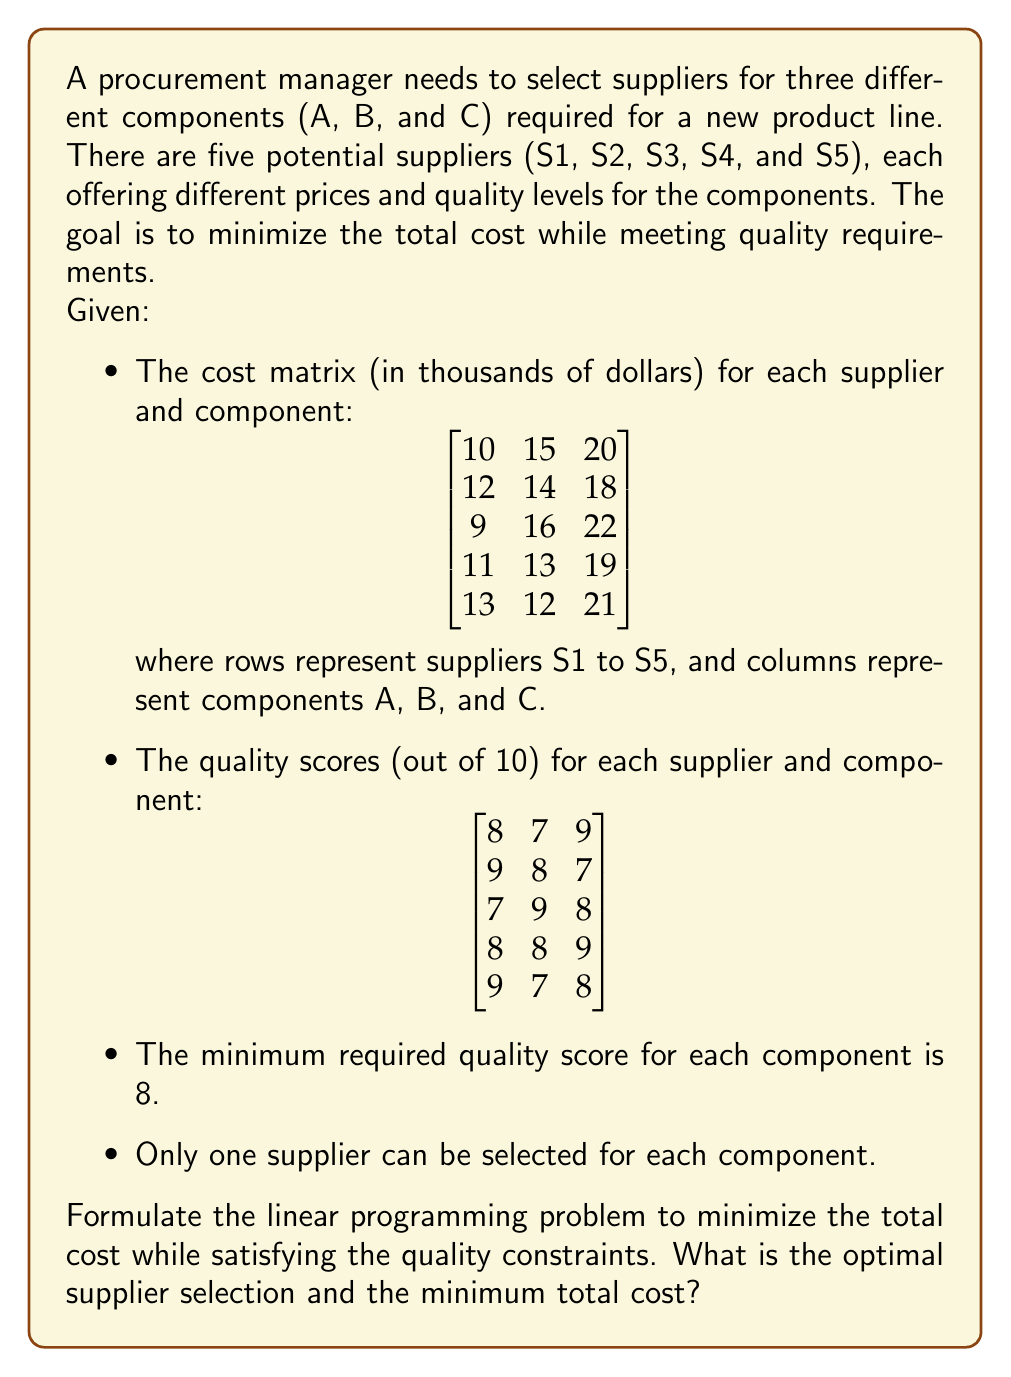Teach me how to tackle this problem. To solve this problem, we'll use binary decision variables and formulate a linear programming problem.

Step 1: Define decision variables
Let $x_{ij}$ be a binary variable where i represents the supplier (1 to 5) and j represents the component (1 to 3).
$x_{ij} = 1$ if supplier i is selected for component j, and 0 otherwise.

Step 2: Formulate the objective function
Minimize the total cost:
$$\min Z = \sum_{i=1}^{5}\sum_{j=1}^{3} c_{ij}x_{ij}$$
where $c_{ij}$ is the cost of component j from supplier i.

Step 3: Define constraints

1. Quality constraints:
   For each component j:
   $$\sum_{i=1}^{5} q_{ij}x_{ij} \geq 8$$
   where $q_{ij}$ is the quality score of component j from supplier i.

2. Single supplier constraint:
   For each component j:
   $$\sum_{i=1}^{5} x_{ij} = 1$$

3. Binary constraint:
   $$x_{ij} \in \{0,1\}$$

Step 4: Solve the linear programming problem

The complete formulation:

Minimize:
$$Z = 10x_{11} + 15x_{12} + 20x_{13} + 12x_{21} + 14x_{22} + 18x_{23} + 9x_{31} + 16x_{32} + 22x_{33} + 11x_{41} + 13x_{42} + 19x_{43} + 13x_{51} + 12x_{52} + 21x_{53}$$

Subject to:
$$8x_{11} + 9x_{21} + 7x_{31} + 8x_{41} + 9x_{51} \geq 8$$
$$7x_{12} + 8x_{22} + 9x_{32} + 8x_{42} + 7x_{52} \geq 8$$
$$9x_{13} + 7x_{23} + 8x_{33} + 9x_{43} + 8x_{53} \geq 8$$

$$x_{11} + x_{21} + x_{31} + x_{41} + x_{51} = 1$$
$$x_{12} + x_{22} + x_{32} + x_{42} + x_{52} = 1$$
$$x_{13} + x_{23} + x_{33} + x_{43} + x_{53} = 1$$

$$x_{ij} \in \{0,1\} \text{ for all i and j}$$

Solving this linear programming problem using a solver, we get the optimal solution:
- Component A: Supplier 3 ($x_{31} = 1$)
- Component B: Supplier 5 ($x_{52} = 1$)
- Component C: Supplier 2 ($x_{23} = 1$)

The minimum total cost is:
$$Z = 9 + 12 + 18 = 39$$
Answer: The optimal supplier selection is:
- Component A: Supplier 3
- Component B: Supplier 5
- Component C: Supplier 2

The minimum total cost is $39,000. 